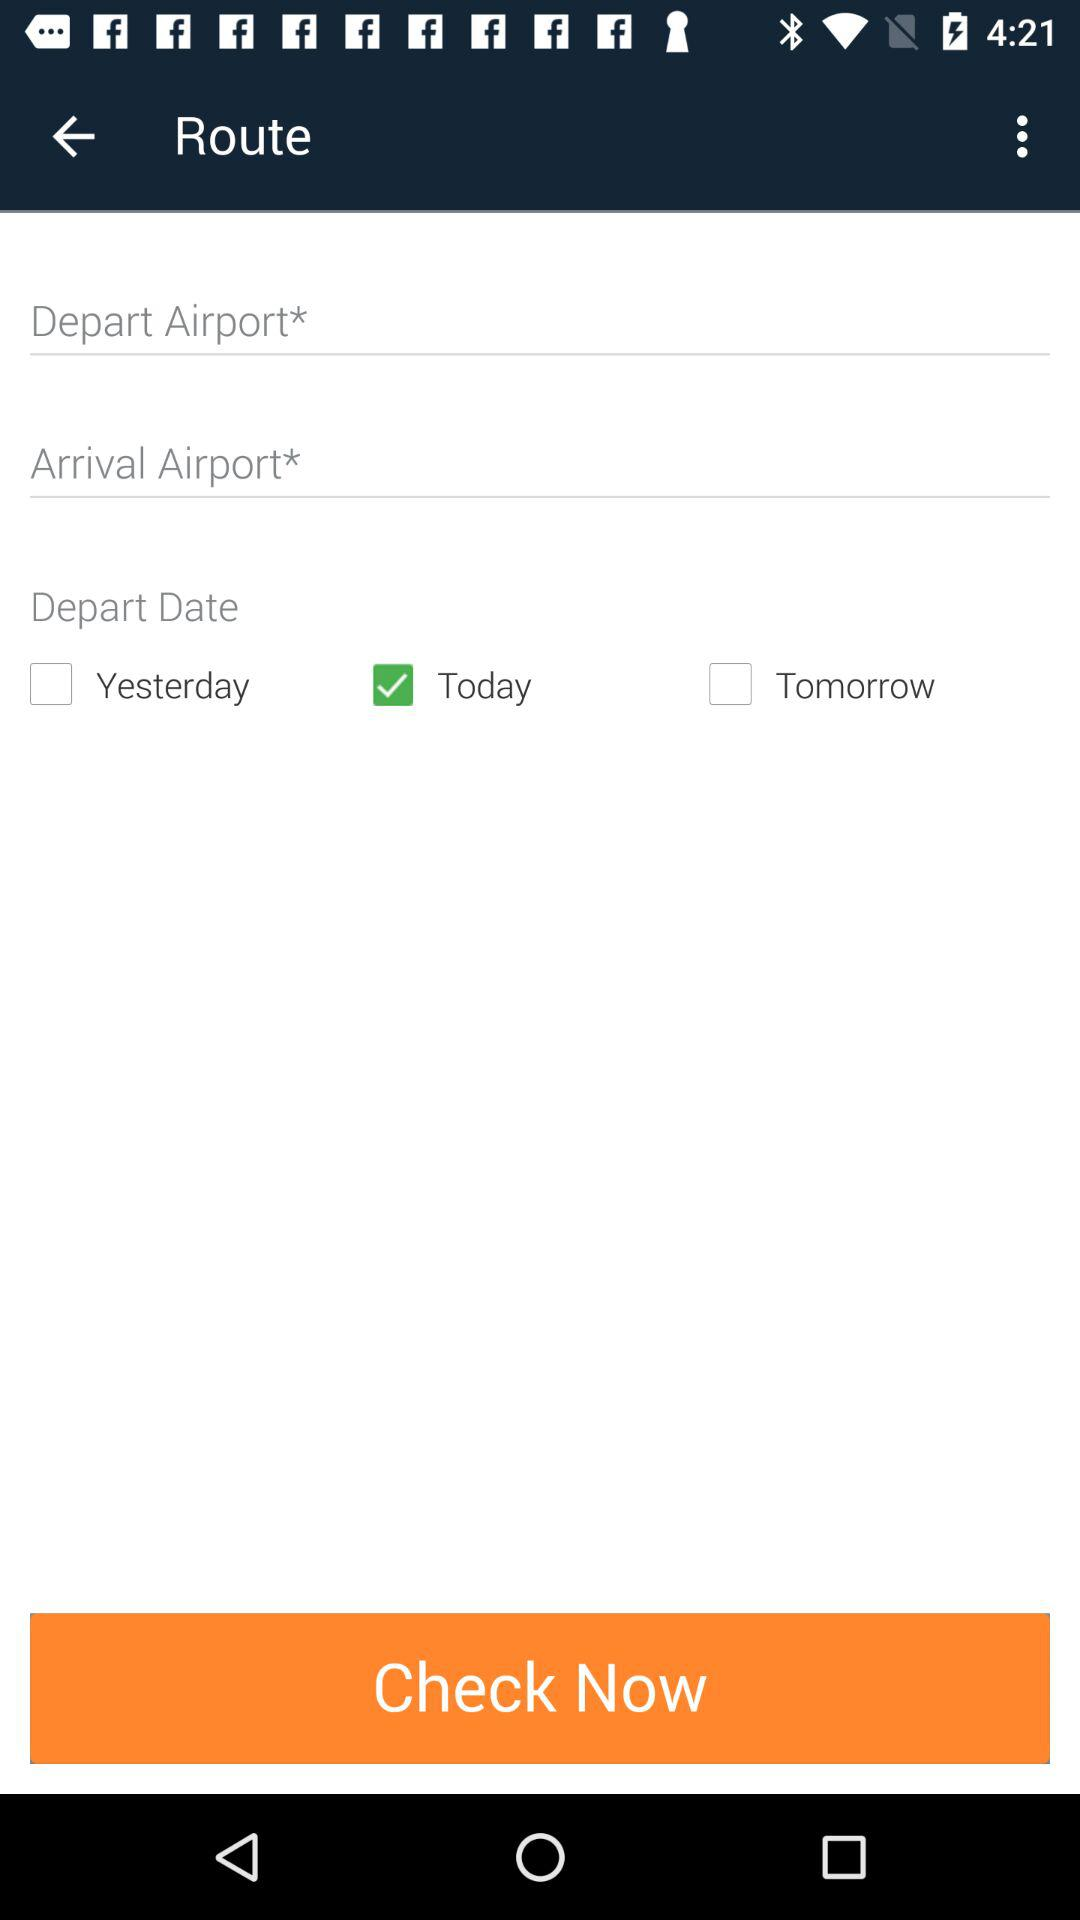How many days are available for departure?
Answer the question using a single word or phrase. 3 